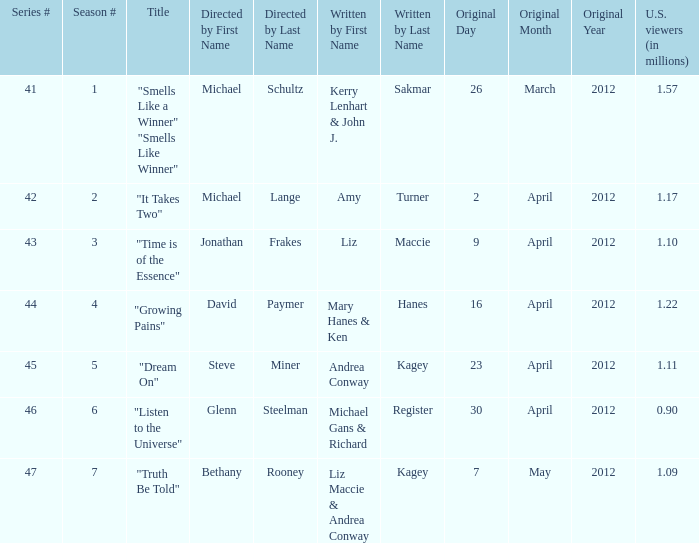What is the title of the episode/s written by Michael Gans & Richard Register? "Listen to the Universe". 